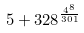<formula> <loc_0><loc_0><loc_500><loc_500>5 + 3 2 8 ^ { \frac { 4 ^ { 8 } } { 3 0 1 } }</formula> 